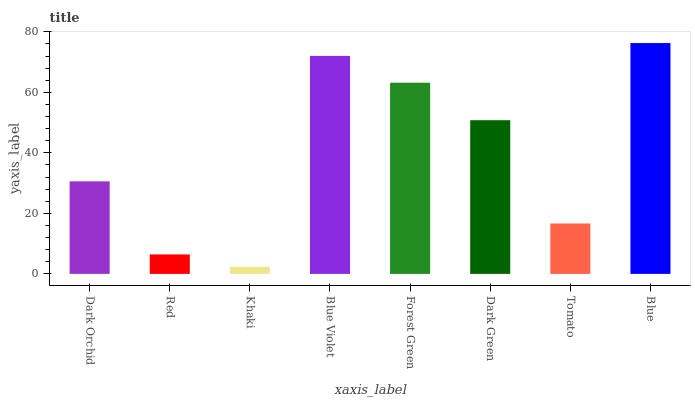Is Khaki the minimum?
Answer yes or no. Yes. Is Blue the maximum?
Answer yes or no. Yes. Is Red the minimum?
Answer yes or no. No. Is Red the maximum?
Answer yes or no. No. Is Dark Orchid greater than Red?
Answer yes or no. Yes. Is Red less than Dark Orchid?
Answer yes or no. Yes. Is Red greater than Dark Orchid?
Answer yes or no. No. Is Dark Orchid less than Red?
Answer yes or no. No. Is Dark Green the high median?
Answer yes or no. Yes. Is Dark Orchid the low median?
Answer yes or no. Yes. Is Red the high median?
Answer yes or no. No. Is Blue the low median?
Answer yes or no. No. 